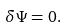Convert formula to latex. <formula><loc_0><loc_0><loc_500><loc_500>\delta \Psi = 0 .</formula> 